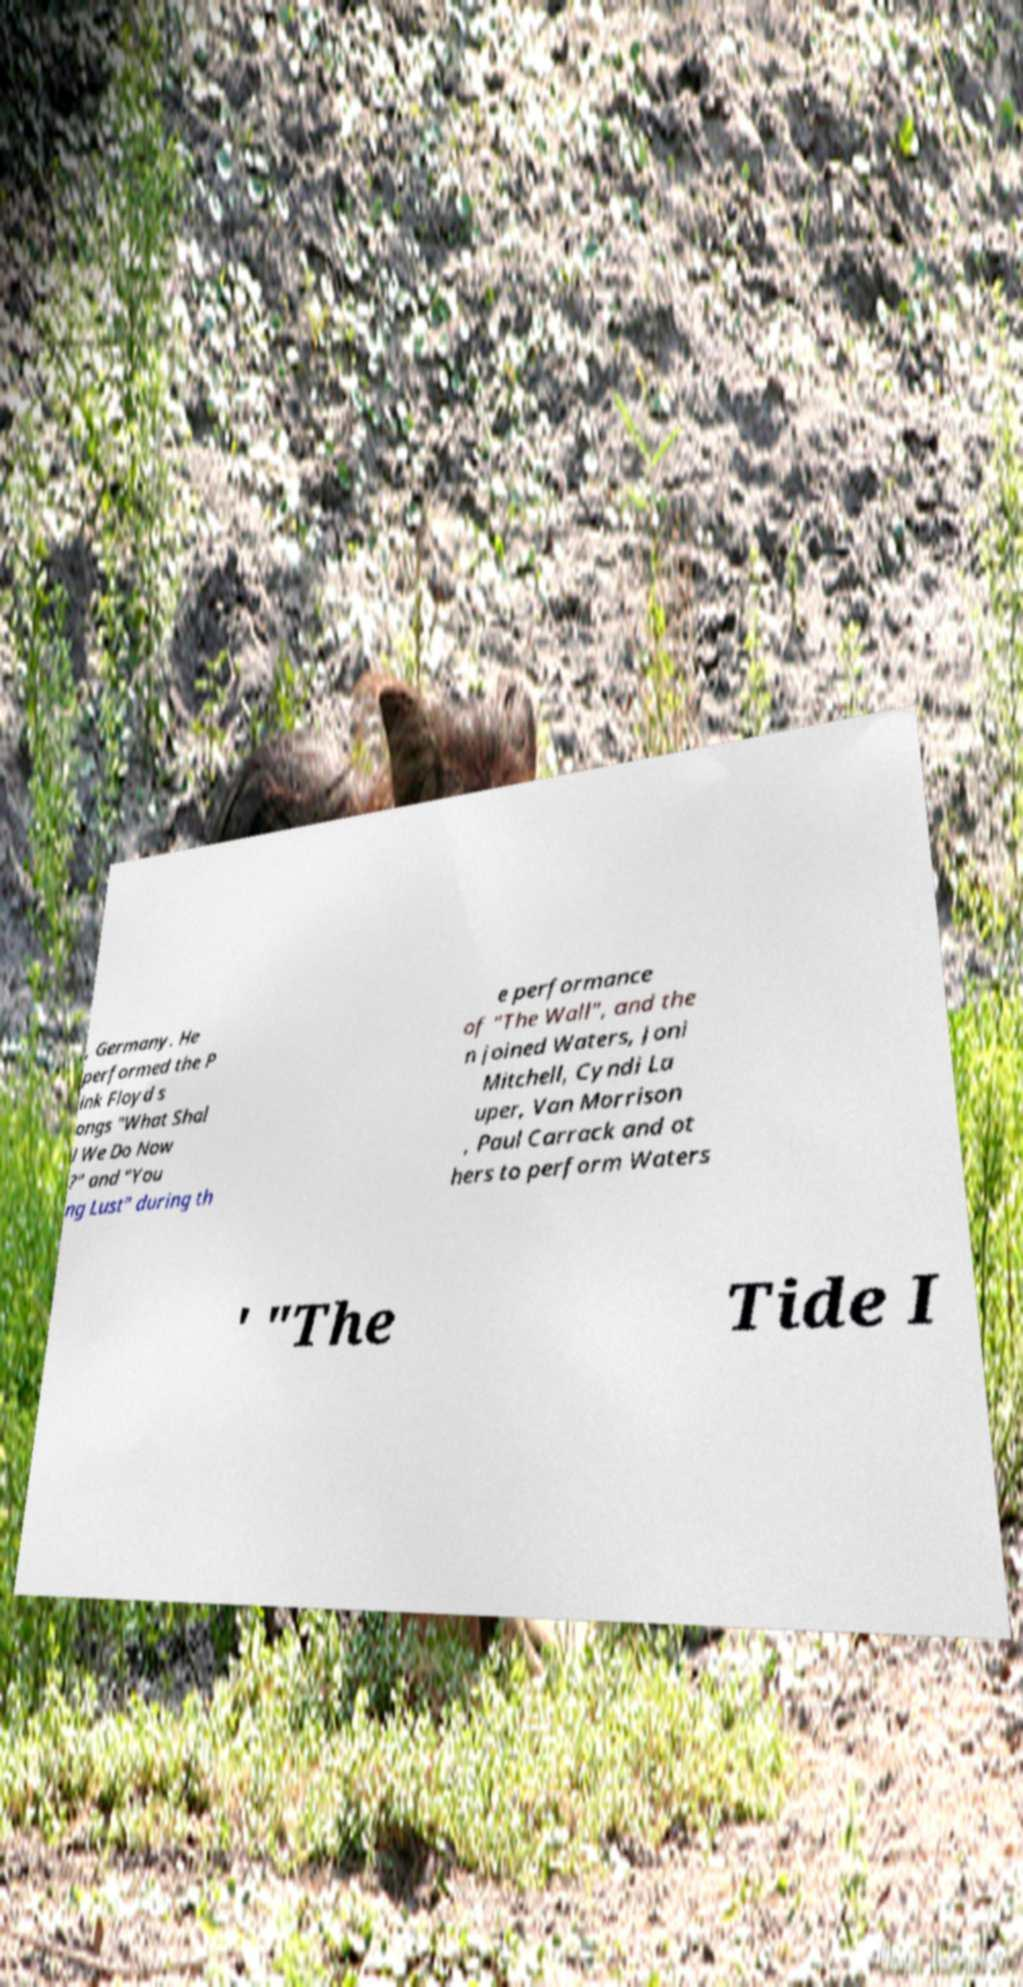Can you read and provide the text displayed in the image?This photo seems to have some interesting text. Can you extract and type it out for me? , Germany. He performed the P ink Floyd s ongs "What Shal l We Do Now ?" and "You ng Lust" during th e performance of "The Wall", and the n joined Waters, Joni Mitchell, Cyndi La uper, Van Morrison , Paul Carrack and ot hers to perform Waters ' "The Tide I 